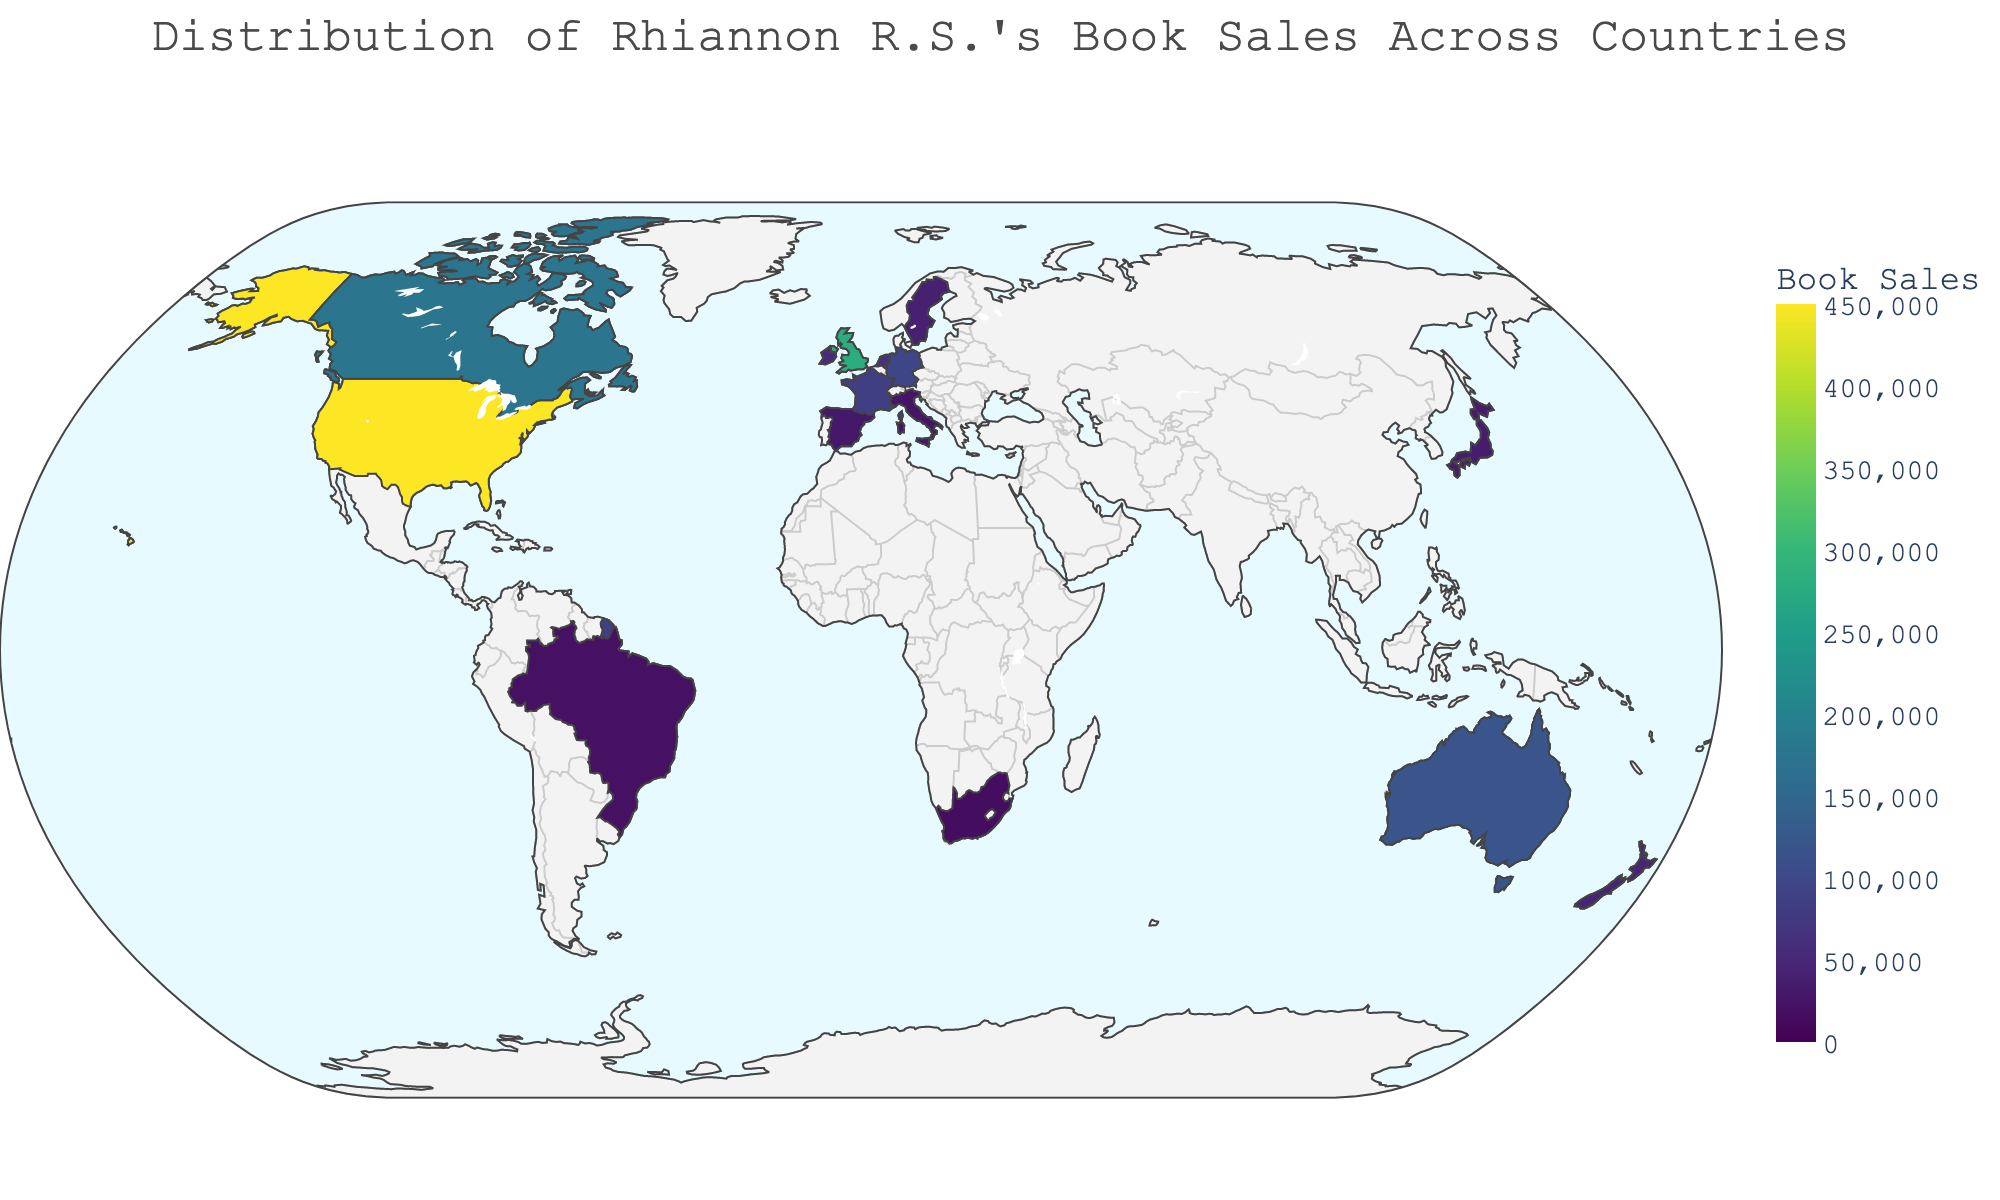Which country has the highest book sales? By looking at the choropleth map, the United States has the highest color intensity indicating the highest sales.
Answer: United States Which country has the lowest book sales? By looking at the choropleth map, South Africa has the lowest color intensity indicating the lowest sales.
Answer: South Africa How many countries are shown in the figure? By counting the number of unique countries displayed on the map, we find there are 15 countries represented.
Answer: 15 What is the total sum of book sales for France and Germany? The book sales for France are 85,000 and for Germany are 95,000. By summing these values, 85,000 + 95,000 = 180,000.
Answer: 180,000 Which country has more book sales, Canada or Australia? By comparing the sales values, Canada has 175,000 sales and Australia has 120,000 sales. Canada has more sales.
Answer: Canada What is the average book sales for all countries in Europe listed in the map? The European countries listed are the United Kingdom, Germany, France, Netherlands, Ireland, Sweden, Spain, and Italy. Summing their sales (280,000 + 95,000 + 85,000 + 65,000 + 55,000 + 40,000 + 30,000 + 25,000 = 675,000) and dividing by the number of countries (8), 675,000 / 8 = 84,375.
Answer: 84,375 Which country has about half the book sales of the United Kingdom? The United Kingdom has 280,000 sales. Roughly half of that is 140,000. Australia, with 120,000, is the closest to half.
Answer: Australia What is the difference in book sales between Japan and Brazil? Sales in Japan are 35,000 and in Brazil are 20,000. The difference is 35,000 - 20,000 = 15,000.
Answer: 15,000 Identify a country with book sales between 50,000 and 100,000. By looking at the figures, the Netherlands has 65,000 book sales, falling within the range of 50,000 and 100,000.
Answer: Netherlands What percentage of the total book sales are from the United States? The total sales are the sum of all sales in each country (1,450,000). The United States has 450,000 sales. The percentage is (450,000 / 1,450,000) * 100 = 31.03%.
Answer: 31.03% 